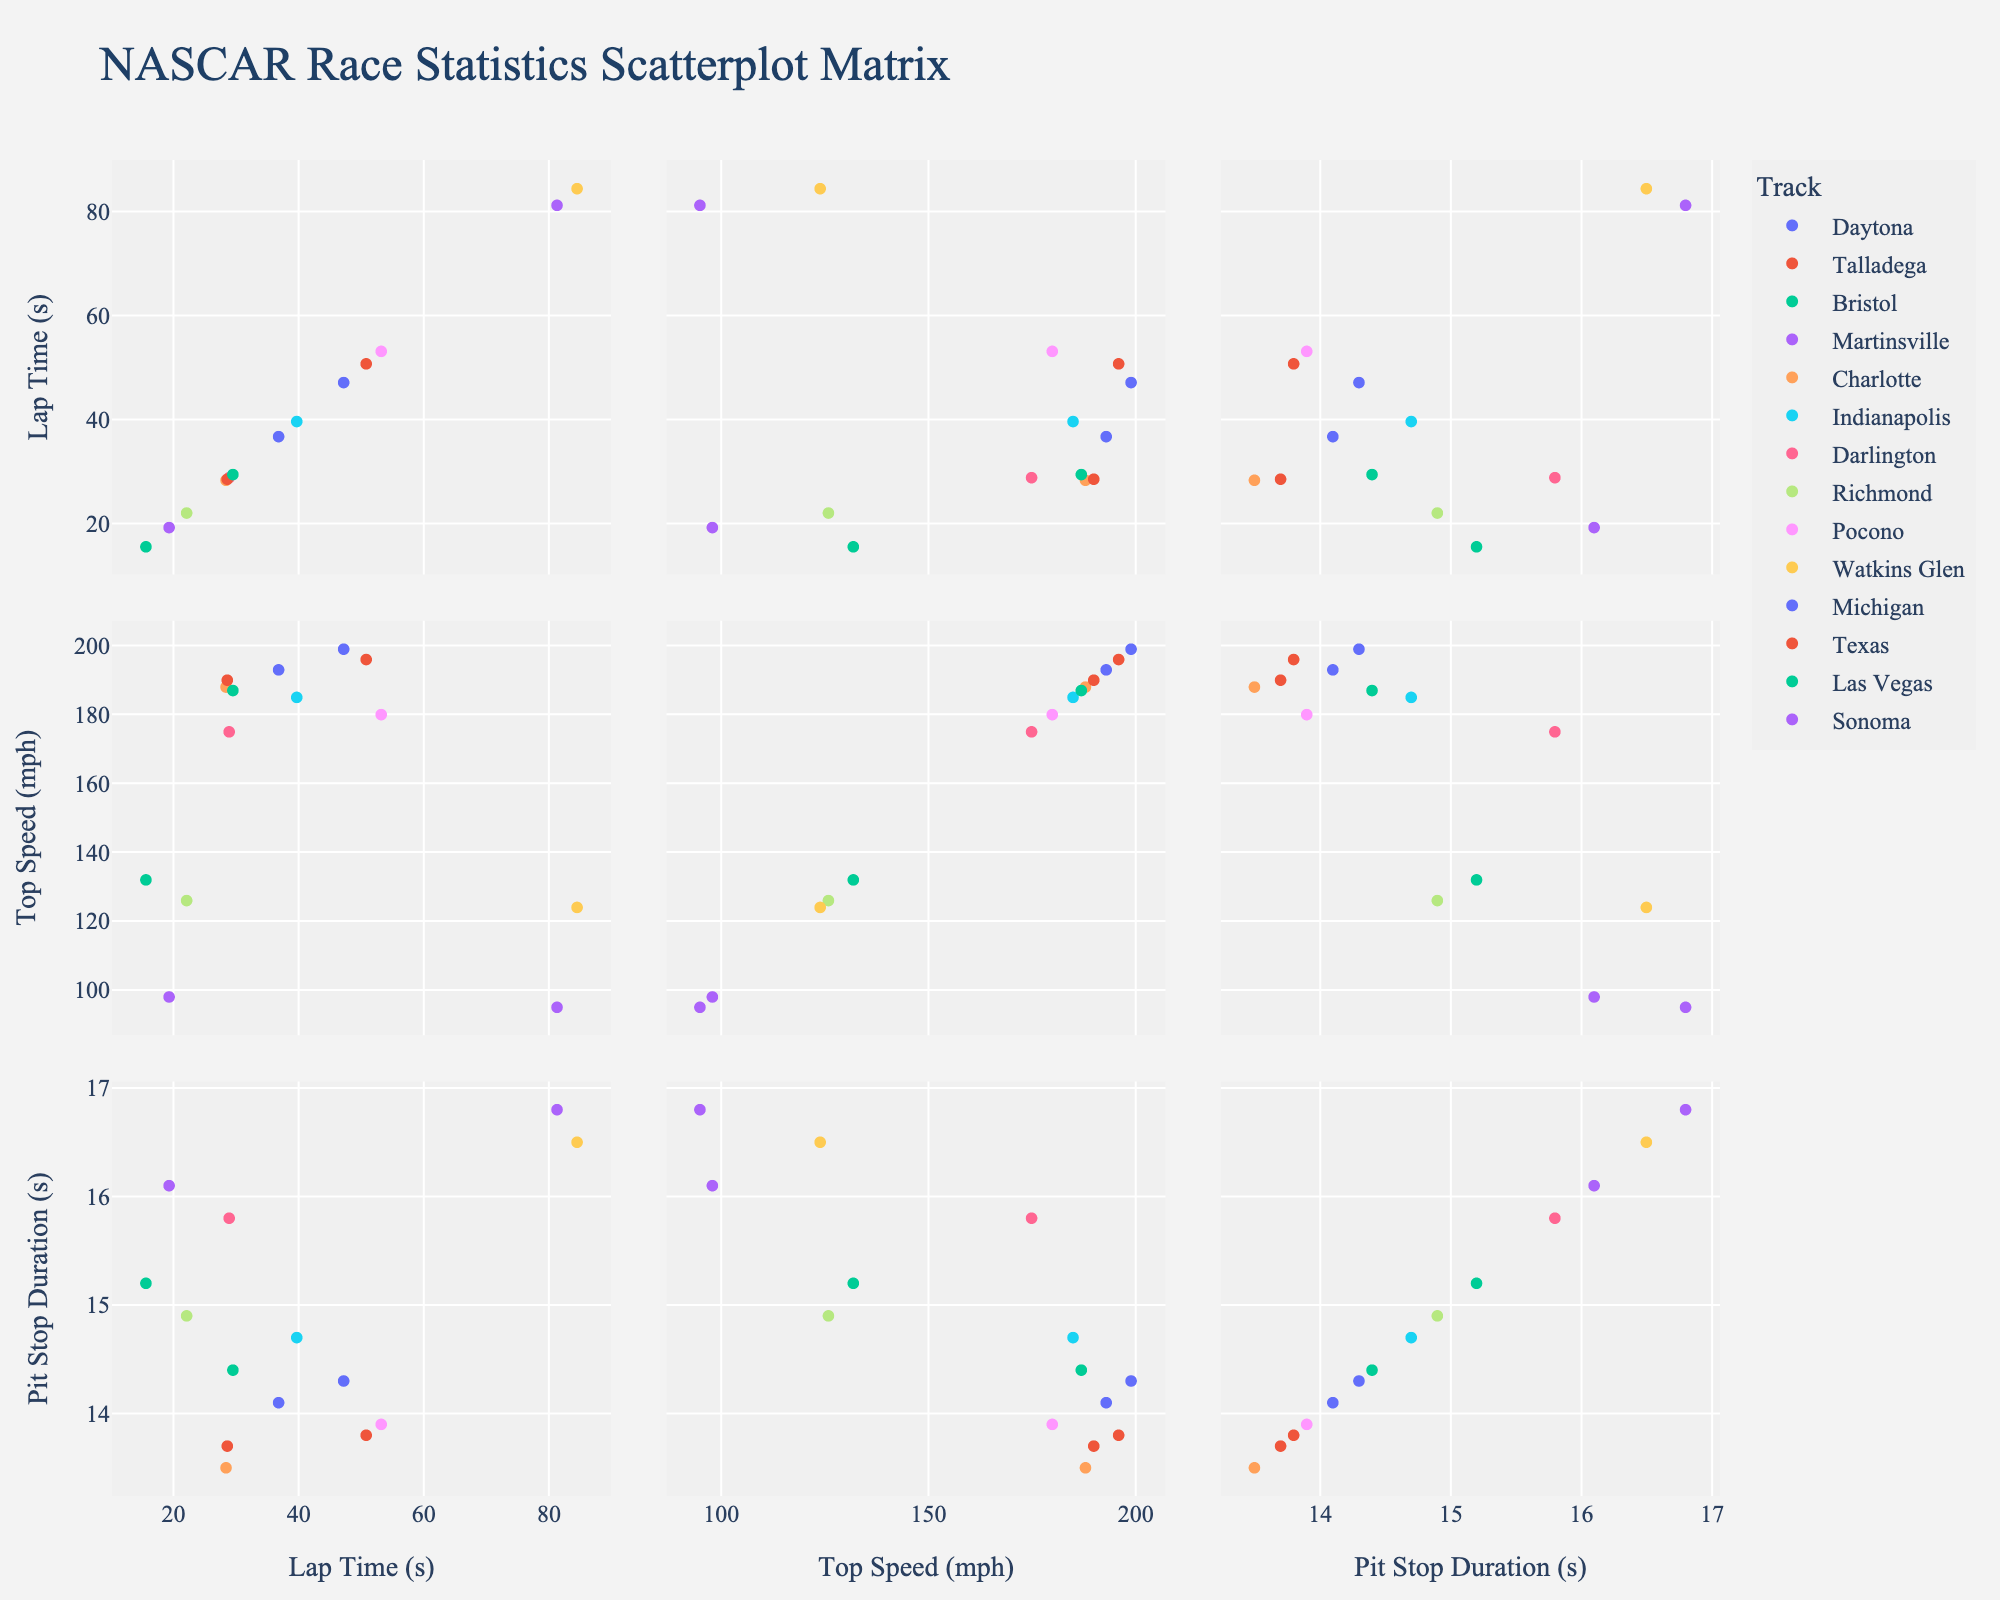What is the title of the scatterplot matrix? The title of the scatterplot matrix is prominently displayed at the top of the chart.
Answer: NASCAR Race Statistics Scatterplot Matrix How many tracks are represented in the scatterplot matrix? By counting the number of distinct tracks listed in the scatterplot matrix legend, we can determine the total number.
Answer: 14 Which track has the highest lap time? Look for the highest value on the Lap Time (s) axis and identify the track associated with that data point.
Answer: Watkins Glen Which track has the lowest top speed? Look for the lowest value on the Top Speed (mph) axis and identify the track associated with that data point.
Answer: Sonoma What is the average lap time across all tracks? Sum all the lap time values and divide by the number of tracks. (47.2 + 50.8 + 15.6 + 19.3 + 28.4 + 39.7 + 28.9 + 22.1 + 53.2 + 84.5 + 36.8 + 28.6 + 29.5 + 81.3) / 14 ≈ 39.6 seconds
Answer: 39.6 seconds Do tracks with higher top speeds generally have shorter lap times? Identify whether there is a visible inverse relationship between Top Speed (mph) and Lap Time (s) across the tracks in the scatterplot.
Answer: Yes Which track has the longest pit stop duration? Look for the highest value on the Pit Stop Duration (s) axis and identify the track associated with that data point.
Answer: Sonoma Is there a clear correlation between lap time and top speed? Look at the scatterplot for lap time vs. top speed and determine if the data points align along a trend line suggesting a correlation.
Answer: Negative correlation Which two tracks have similar top speeds but significant differences in lap times? Compare the data points in the Top Speed (mph) vs. Lap Time (s) plane and find two points close in top speed but far apart in lap times.
Answer: Daytona and Charlotte What is the median pit stop duration across all tracks? Arrange the pit stop durations in ascending order and find the middle value. (13.5, 13.7, 13.8, 13.9, 14.1, 14.3, 14.4, 14.7, 14.9, 15.2, 15.8, 16.1, 16.5, 16.8), the middle values are 14.4 and 14.7, the median is (14.4 + 14.7) / 2 = 14.55 seconds
Answer: 14.55 seconds 